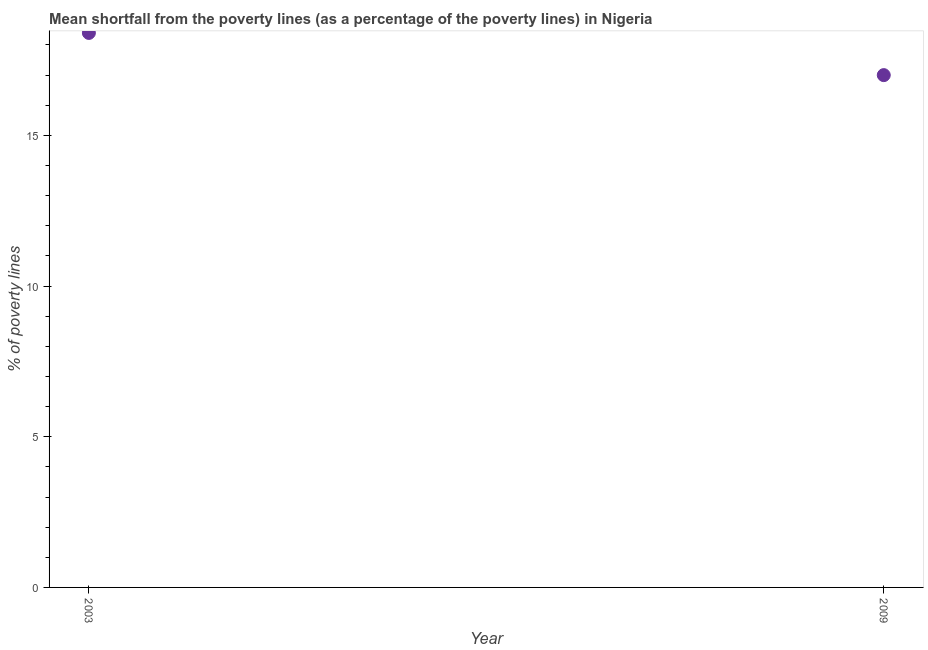What is the poverty gap at national poverty lines in 2009?
Your response must be concise. 17. Across all years, what is the maximum poverty gap at national poverty lines?
Provide a succinct answer. 18.4. Across all years, what is the minimum poverty gap at national poverty lines?
Your answer should be very brief. 17. In which year was the poverty gap at national poverty lines maximum?
Your response must be concise. 2003. What is the sum of the poverty gap at national poverty lines?
Provide a short and direct response. 35.4. What is the difference between the poverty gap at national poverty lines in 2003 and 2009?
Make the answer very short. 1.4. What is the average poverty gap at national poverty lines per year?
Your answer should be compact. 17.7. What is the ratio of the poverty gap at national poverty lines in 2003 to that in 2009?
Provide a short and direct response. 1.08. Is the poverty gap at national poverty lines in 2003 less than that in 2009?
Give a very brief answer. No. In how many years, is the poverty gap at national poverty lines greater than the average poverty gap at national poverty lines taken over all years?
Provide a short and direct response. 1. How many years are there in the graph?
Give a very brief answer. 2. What is the difference between two consecutive major ticks on the Y-axis?
Make the answer very short. 5. Does the graph contain any zero values?
Offer a terse response. No. What is the title of the graph?
Provide a succinct answer. Mean shortfall from the poverty lines (as a percentage of the poverty lines) in Nigeria. What is the label or title of the Y-axis?
Your answer should be very brief. % of poverty lines. What is the % of poverty lines in 2009?
Give a very brief answer. 17. What is the difference between the % of poverty lines in 2003 and 2009?
Your response must be concise. 1.4. What is the ratio of the % of poverty lines in 2003 to that in 2009?
Keep it short and to the point. 1.08. 